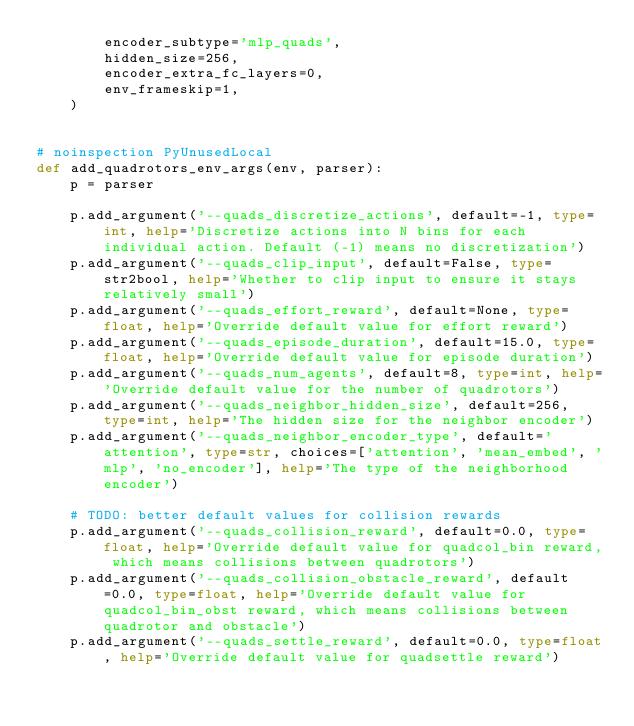Convert code to text. <code><loc_0><loc_0><loc_500><loc_500><_Python_>        encoder_subtype='mlp_quads',
        hidden_size=256,
        encoder_extra_fc_layers=0,
        env_frameskip=1,
    )


# noinspection PyUnusedLocal
def add_quadrotors_env_args(env, parser):
    p = parser

    p.add_argument('--quads_discretize_actions', default=-1, type=int, help='Discretize actions into N bins for each individual action. Default (-1) means no discretization')
    p.add_argument('--quads_clip_input', default=False, type=str2bool, help='Whether to clip input to ensure it stays relatively small')
    p.add_argument('--quads_effort_reward', default=None, type=float, help='Override default value for effort reward')
    p.add_argument('--quads_episode_duration', default=15.0, type=float, help='Override default value for episode duration')
    p.add_argument('--quads_num_agents', default=8, type=int, help='Override default value for the number of quadrotors')
    p.add_argument('--quads_neighbor_hidden_size', default=256, type=int, help='The hidden size for the neighbor encoder')
    p.add_argument('--quads_neighbor_encoder_type', default='attention', type=str, choices=['attention', 'mean_embed', 'mlp', 'no_encoder'], help='The type of the neighborhood encoder')

    # TODO: better default values for collision rewards
    p.add_argument('--quads_collision_reward', default=0.0, type=float, help='Override default value for quadcol_bin reward, which means collisions between quadrotors')
    p.add_argument('--quads_collision_obstacle_reward', default=0.0, type=float, help='Override default value for quadcol_bin_obst reward, which means collisions between quadrotor and obstacle')
    p.add_argument('--quads_settle_reward', default=0.0, type=float, help='Override default value for quadsettle reward')</code> 